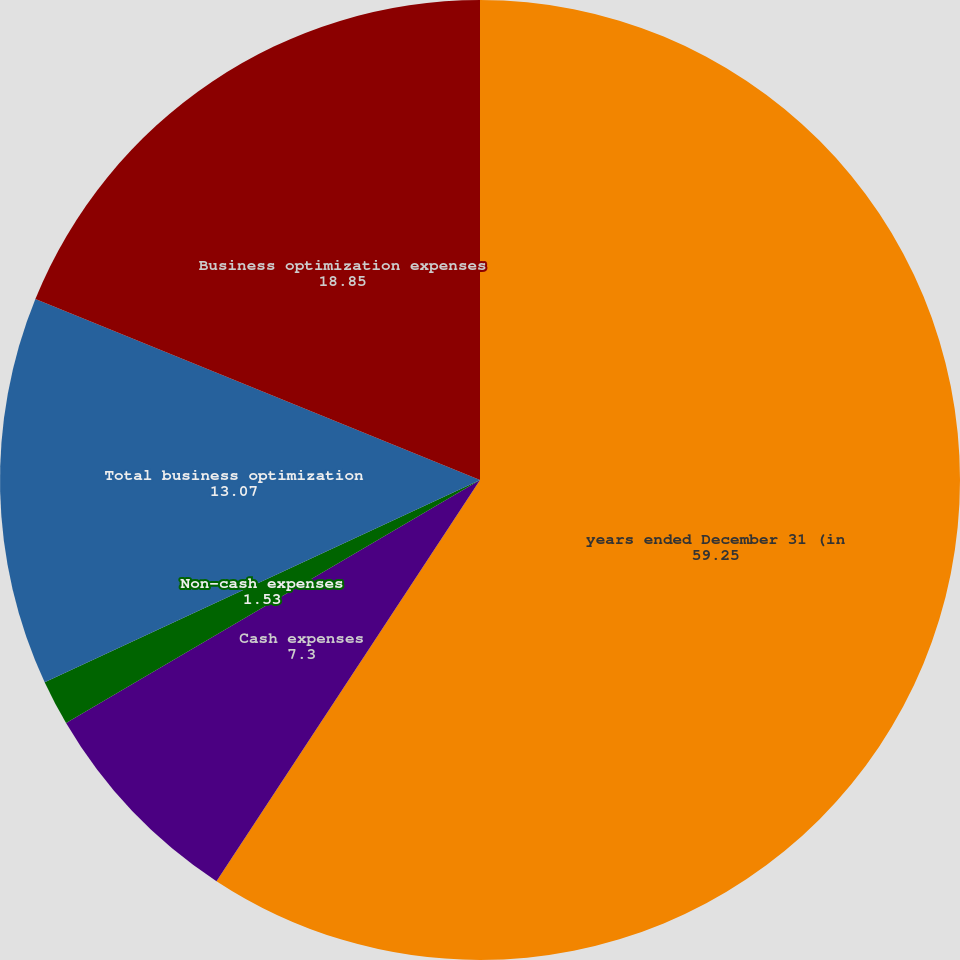Convert chart. <chart><loc_0><loc_0><loc_500><loc_500><pie_chart><fcel>years ended December 31 (in<fcel>Cash expenses<fcel>Non-cash expenses<fcel>Total business optimization<fcel>Business optimization expenses<nl><fcel>59.25%<fcel>7.3%<fcel>1.53%<fcel>13.07%<fcel>18.85%<nl></chart> 